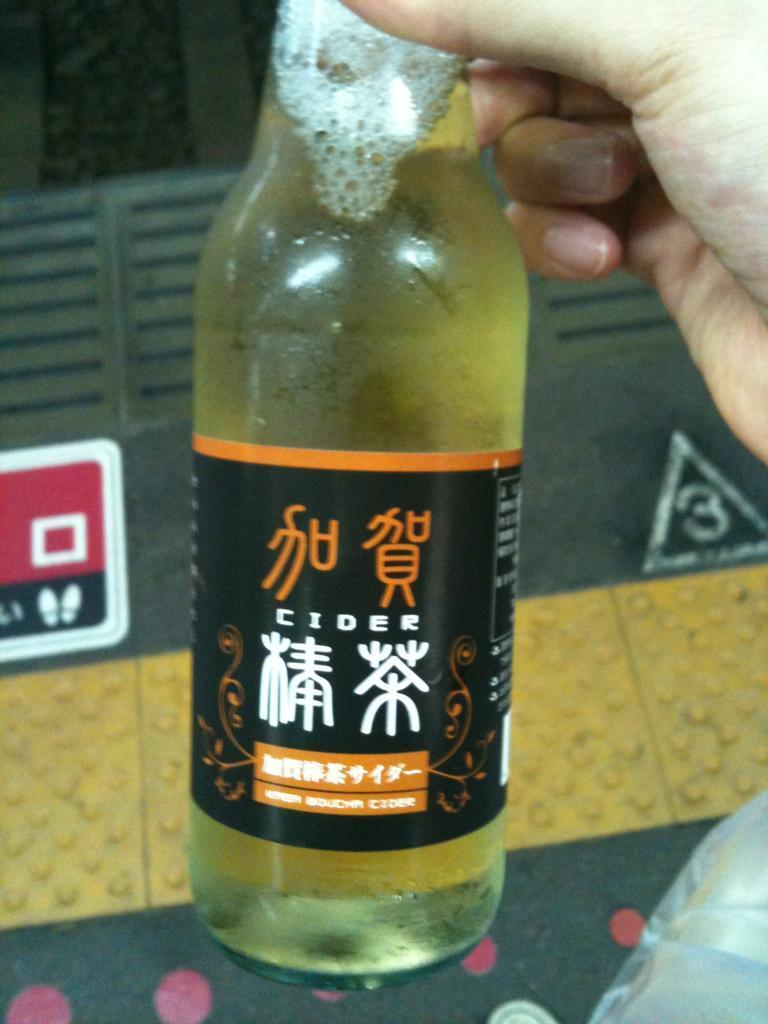<image>
Describe the image concisely. Person holding a bottle of Cider with yellow liquid inside. 